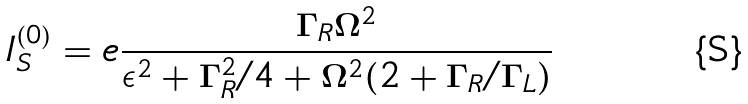Convert formula to latex. <formula><loc_0><loc_0><loc_500><loc_500>I ^ { ( 0 ) } _ { S } = e \frac { \Gamma _ { R } \Omega ^ { 2 } } { \epsilon ^ { 2 } + \Gamma ^ { 2 } _ { R } / 4 + \Omega ^ { 2 } ( 2 + \Gamma _ { R } / \Gamma _ { L } ) }</formula> 